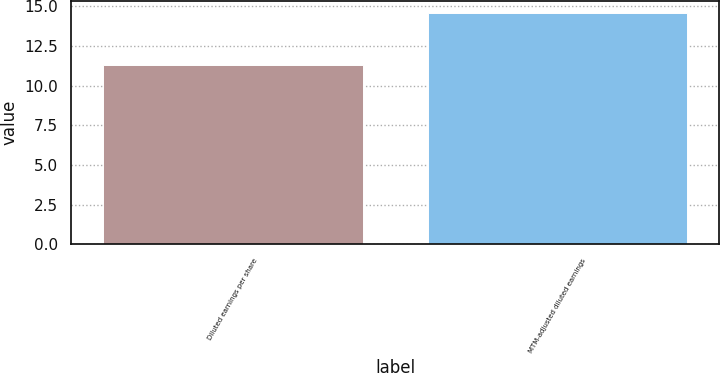<chart> <loc_0><loc_0><loc_500><loc_500><bar_chart><fcel>Diluted earnings per share<fcel>MTM-adjusted diluted earnings<nl><fcel>11.32<fcel>14.59<nl></chart> 